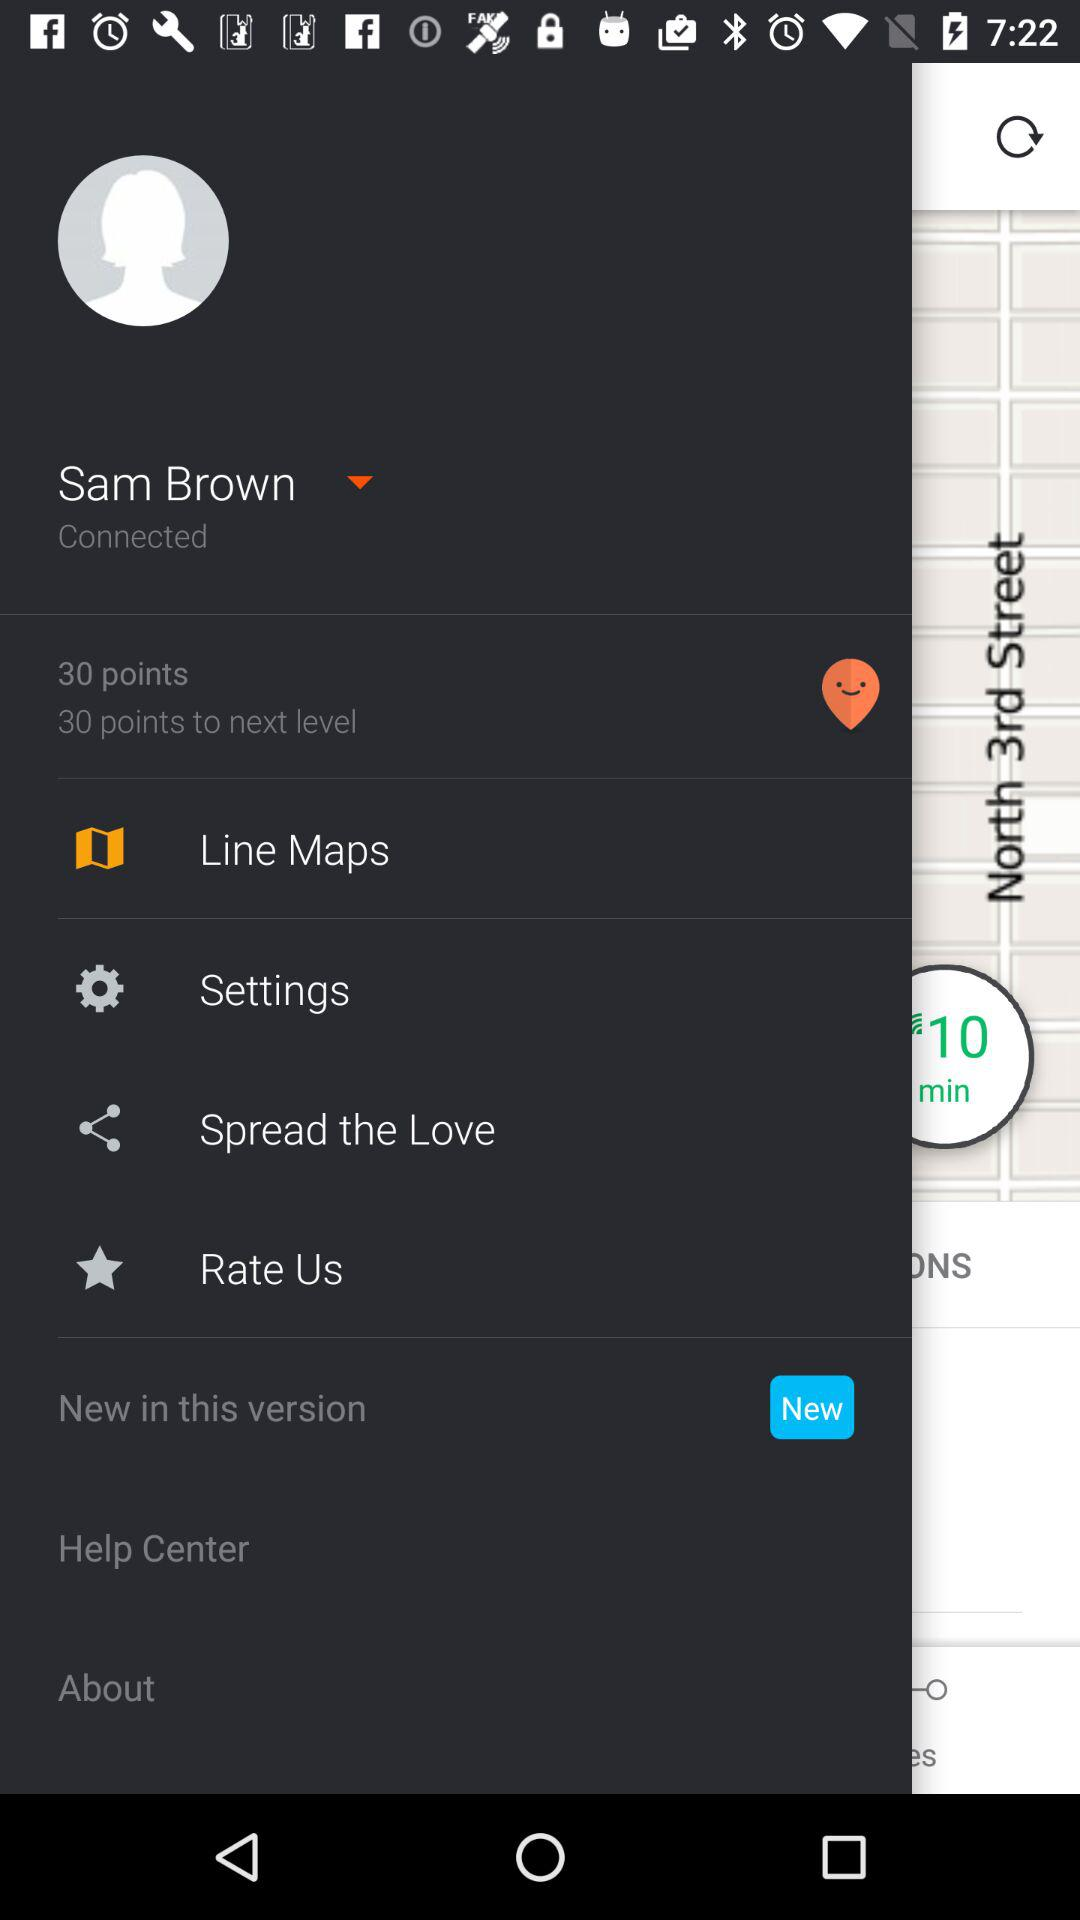What is the name of the user? The name of the user is Sam Brown. 